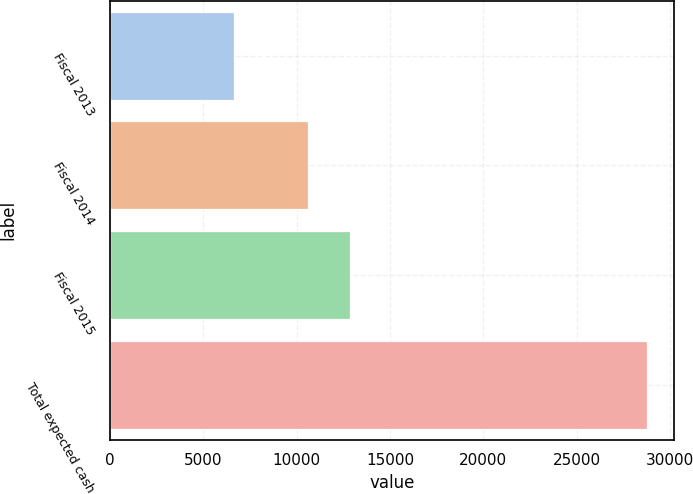<chart> <loc_0><loc_0><loc_500><loc_500><bar_chart><fcel>Fiscal 2013<fcel>Fiscal 2014<fcel>Fiscal 2015<fcel>Total expected cash<nl><fcel>6624<fcel>10616<fcel>12830.5<fcel>28769<nl></chart> 